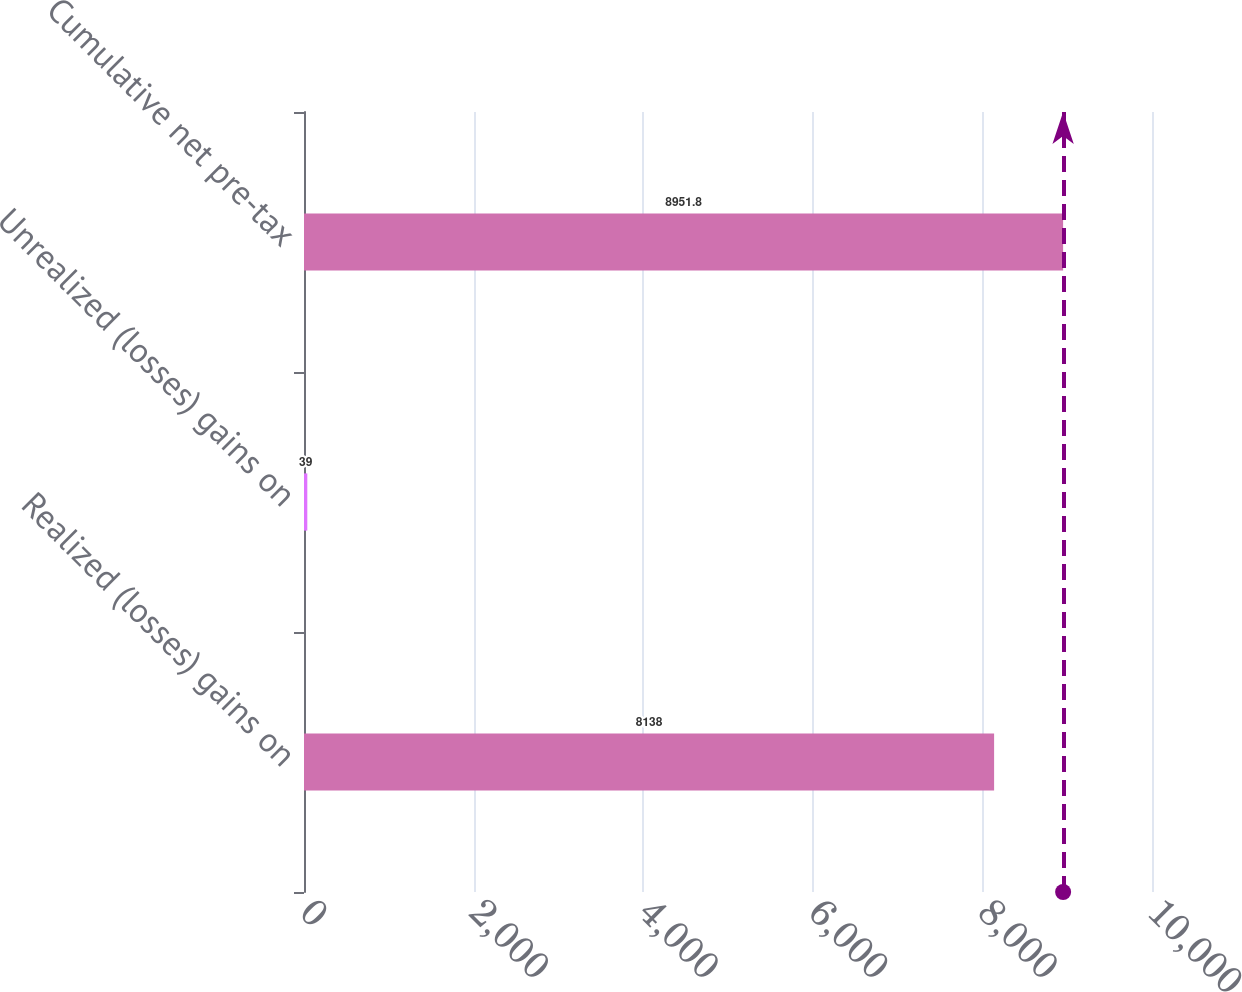Convert chart. <chart><loc_0><loc_0><loc_500><loc_500><bar_chart><fcel>Realized (losses) gains on<fcel>Unrealized (losses) gains on<fcel>Cumulative net pre-tax<nl><fcel>8138<fcel>39<fcel>8951.8<nl></chart> 